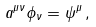Convert formula to latex. <formula><loc_0><loc_0><loc_500><loc_500>a ^ { \mu \nu } \phi _ { \nu } = \psi ^ { \mu } \, ,</formula> 